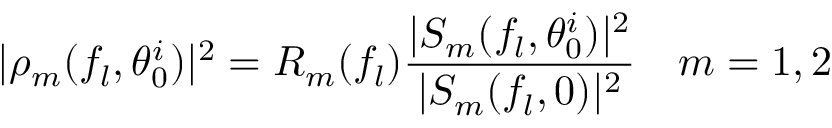<formula> <loc_0><loc_0><loc_500><loc_500>| \rho _ { m } ( f _ { l } , \theta _ { 0 } ^ { i } ) | ^ { 2 } = R _ { m } ( f _ { l } ) \frac { | S _ { m } ( f _ { l } , \theta _ { 0 } ^ { i } ) | ^ { 2 } } { | S _ { m } ( f _ { l } , 0 ) | ^ { 2 } } \quad m = 1 , 2</formula> 